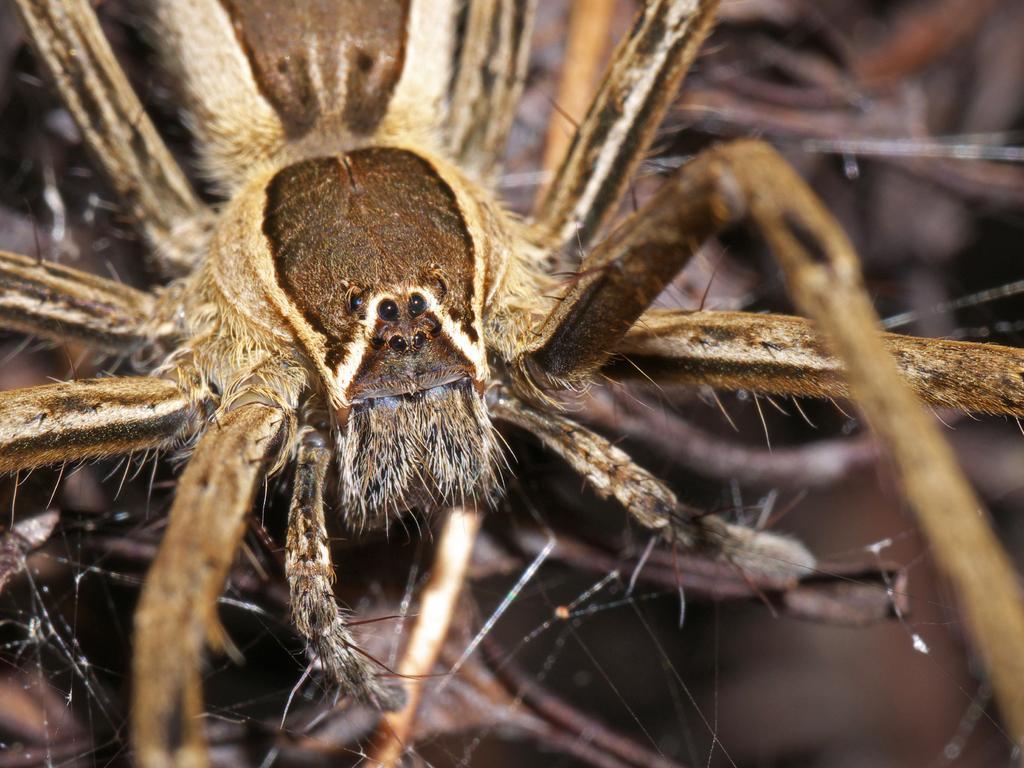In one or two sentences, can you explain what this image depicts? In this image I can see a brown and cream coloured spider. 